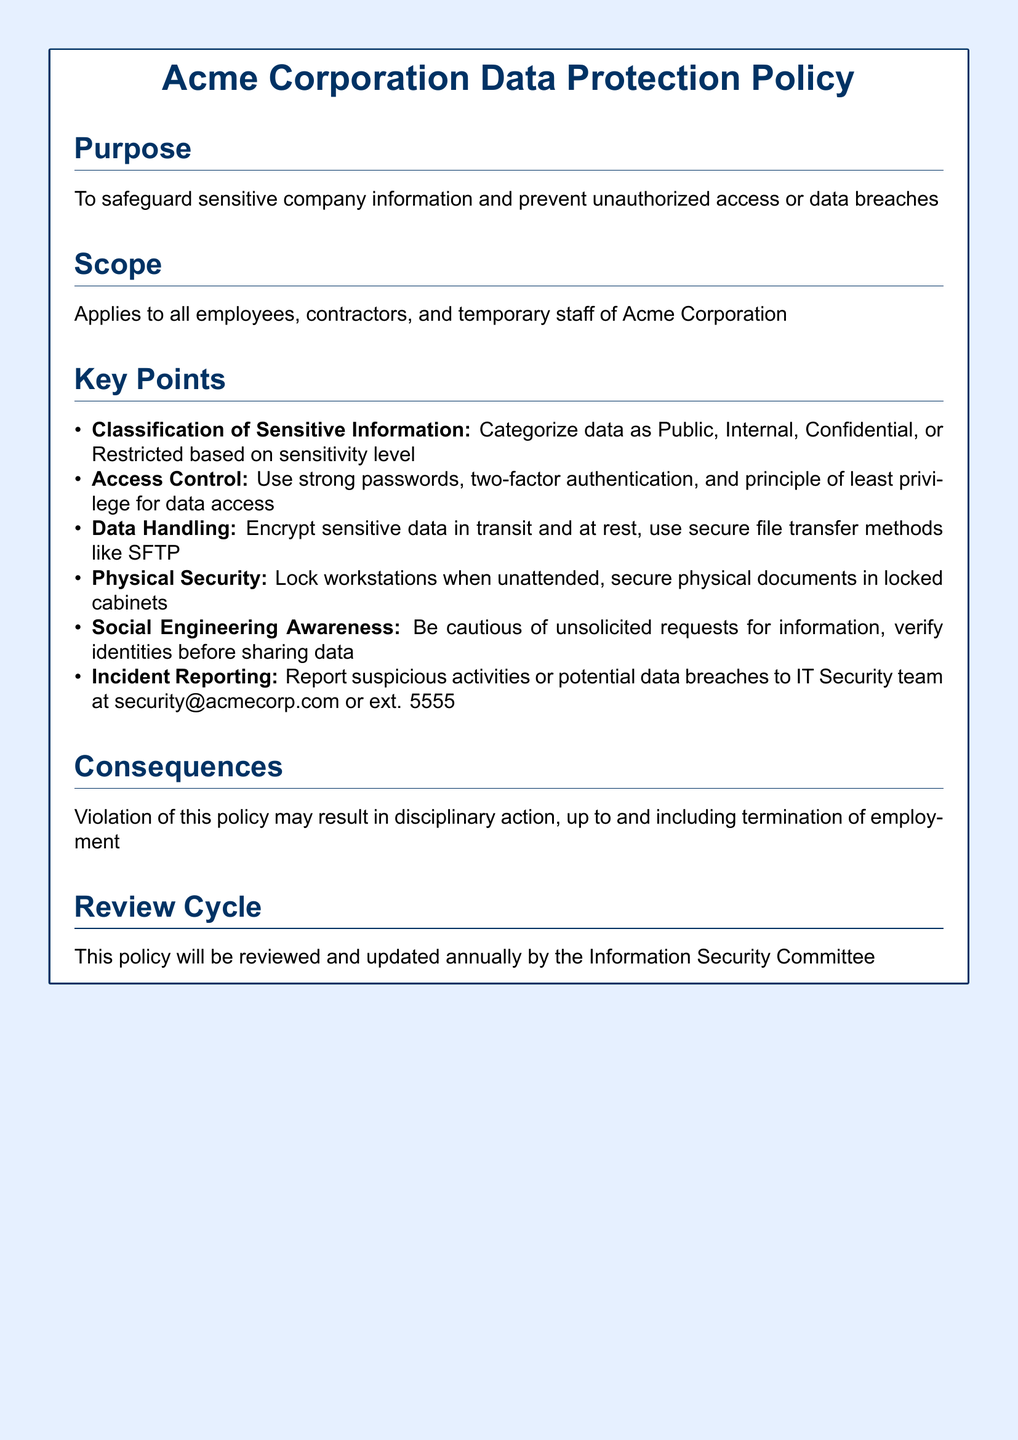What is the purpose of the policy? The purpose of the policy is to safeguard sensitive company information and prevent unauthorized access or data breaches.
Answer: Safeguard sensitive company information Who does this policy apply to? The policy applies to all employees, contractors, and temporary staff of Acme Corporation.
Answer: All employees, contractors, and temporary staff What are the classifications of sensitive information mentioned? The document mentions four classifications of sensitive information: Public, Internal, Confidential, or Restricted.
Answer: Public, Internal, Confidential, Restricted What is the contact for reporting suspicious activities? The contact for reporting suspicious activities is the IT Security team, reachable at security@acmecorp.com or ext. 5555.
Answer: IT Security team What can happen if the policy is violated? Violation of this policy may result in disciplinary action, up to and including termination of employment.
Answer: Disciplinary action, termination How often will the policy be reviewed? The policy will be reviewed and updated annually by the Information Security Committee.
Answer: Annually What security measure is specifically mentioned for data access? The policy specifically mentions the use of strong passwords and two-factor authentication for data access.
Answer: Strong passwords, two-factor authentication 